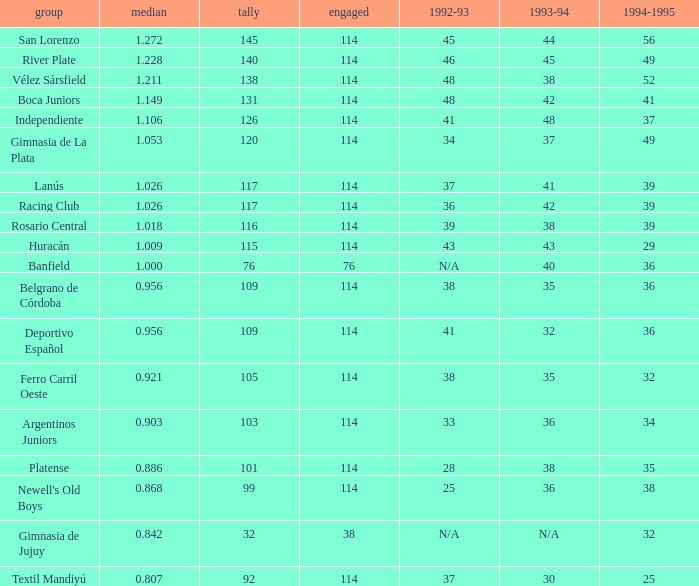Can you parse all the data within this table? {'header': ['group', 'median', 'tally', 'engaged', '1992-93', '1993-94', '1994-1995'], 'rows': [['San Lorenzo', '1.272', '145', '114', '45', '44', '56'], ['River Plate', '1.228', '140', '114', '46', '45', '49'], ['Vélez Sársfield', '1.211', '138', '114', '48', '38', '52'], ['Boca Juniors', '1.149', '131', '114', '48', '42', '41'], ['Independiente', '1.106', '126', '114', '41', '48', '37'], ['Gimnasia de La Plata', '1.053', '120', '114', '34', '37', '49'], ['Lanús', '1.026', '117', '114', '37', '41', '39'], ['Racing Club', '1.026', '117', '114', '36', '42', '39'], ['Rosario Central', '1.018', '116', '114', '39', '38', '39'], ['Huracán', '1.009', '115', '114', '43', '43', '29'], ['Banfield', '1.000', '76', '76', 'N/A', '40', '36'], ['Belgrano de Córdoba', '0.956', '109', '114', '38', '35', '36'], ['Deportivo Español', '0.956', '109', '114', '41', '32', '36'], ['Ferro Carril Oeste', '0.921', '105', '114', '38', '35', '32'], ['Argentinos Juniors', '0.903', '103', '114', '33', '36', '34'], ['Platense', '0.886', '101', '114', '28', '38', '35'], ["Newell's Old Boys", '0.868', '99', '114', '25', '36', '38'], ['Gimnasia de Jujuy', '0.842', '32', '38', 'N/A', 'N/A', '32'], ['Textil Mandiyú', '0.807', '92', '114', '37', '30', '25']]} Name the total number of 1992-93 for 115 points 1.0. 